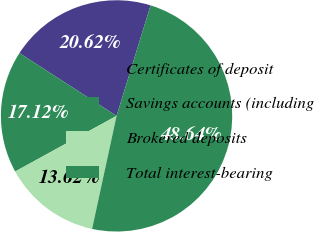Convert chart to OTSL. <chart><loc_0><loc_0><loc_500><loc_500><pie_chart><fcel>Certificates of deposit<fcel>Savings accounts (including<fcel>Brokered deposits<fcel>Total interest-bearing<nl><fcel>20.62%<fcel>17.12%<fcel>13.62%<fcel>48.64%<nl></chart> 